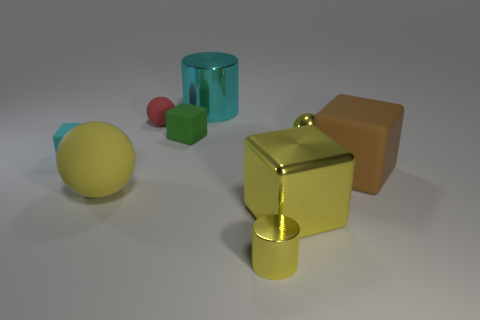Subtract all large yellow cubes. How many cubes are left? 3 Add 1 large matte objects. How many objects exist? 10 Subtract all green cubes. How many cubes are left? 3 Subtract all blocks. How many objects are left? 5 Subtract 2 cylinders. How many cylinders are left? 0 Subtract 0 blue cylinders. How many objects are left? 9 Subtract all brown cylinders. Subtract all green blocks. How many cylinders are left? 2 Subtract all red spheres. How many yellow blocks are left? 1 Subtract all tiny yellow metal cylinders. Subtract all large brown objects. How many objects are left? 7 Add 9 yellow metal cylinders. How many yellow metal cylinders are left? 10 